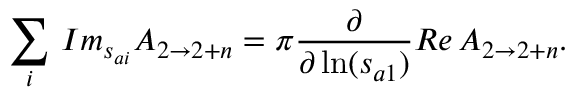<formula> <loc_0><loc_0><loc_500><loc_500>\sum _ { i } \, I m _ { s _ { a i } } A _ { 2 \rightarrow 2 + n } = \pi \frac { \partial } \partial \ln ( s _ { a 1 } ) } R e \, A _ { 2 \rightarrow 2 + n } .</formula> 